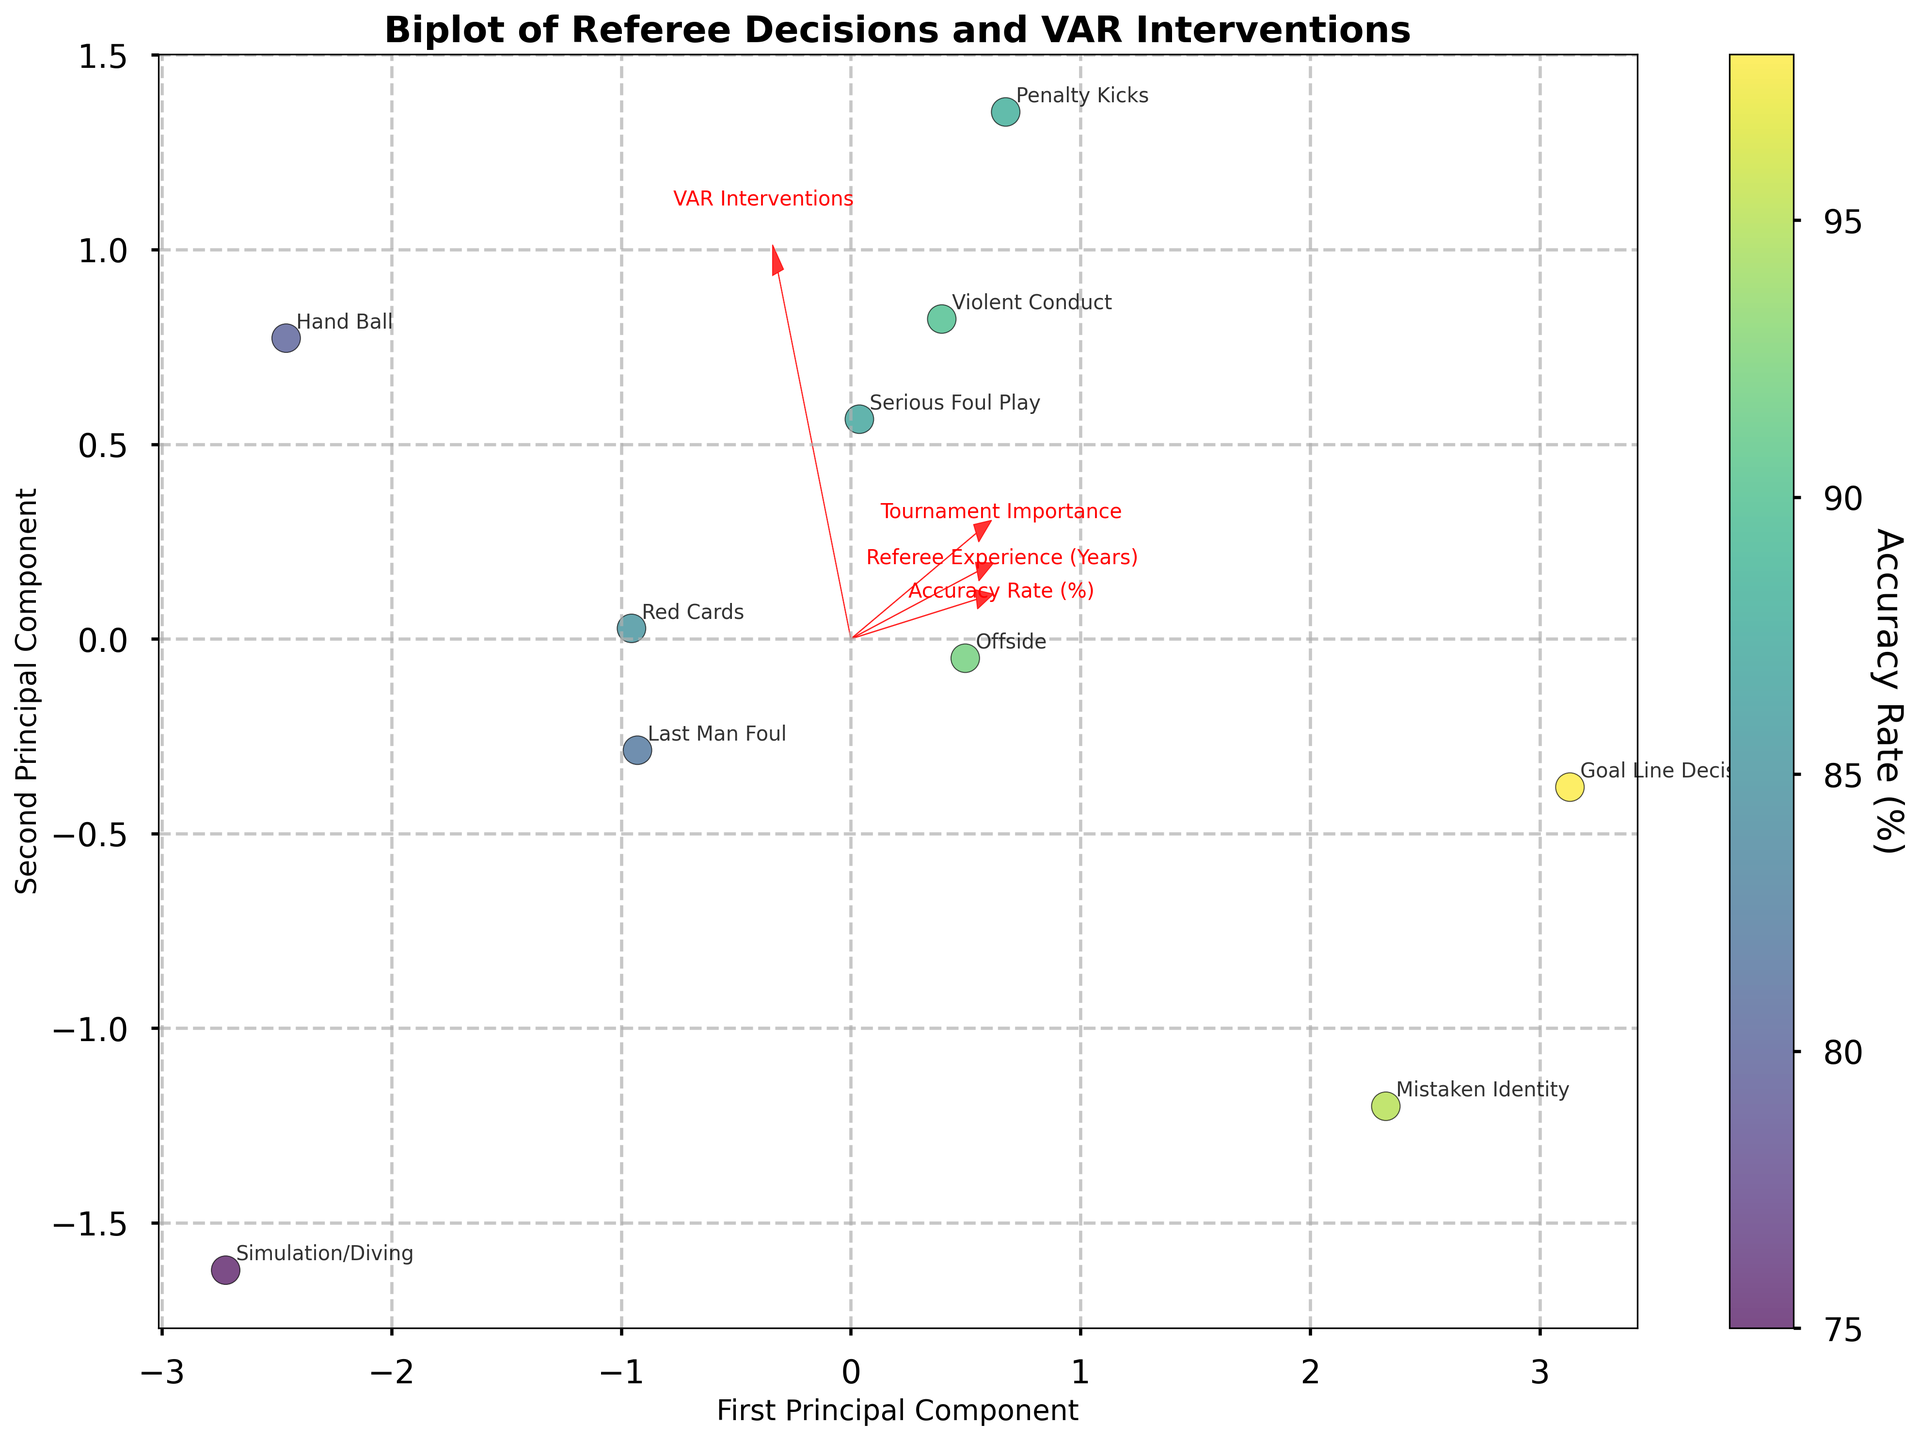What's the title of the plot? The title can usually be found at the top center of the plot and in this case, it reads "Biplot of Referee Decisions and VAR Interventions".
Answer: Biplot of Referee Decisions and VAR Interventions How many principal components are displayed on the axes? The plot shows two axes, each representing a principal component since it's a 2-component PCA biplot.
Answer: 2 What is the label of the color bar? The color bar on the right side of the plot is labeled "Accuracy Rate (%)".
Answer: Accuracy Rate (%) Which decision type has the highest Accuracy Rate (%)? Look for the data point clustered furthest to the right and highest on the color bar. "Goal Line Decisions" are positioned at 98%.
Answer: Goal Line Decisions Which feature vector points most horizontally to the right? Observe the red arrows indicating feature vectors. The arrow labeled "Accuracy Rate (%)" points most horizontally to the right direction.
Answer: Accuracy Rate (%) What's the general trend between Accuracy Rate (%) and VAR Interventions based on the biplot? Look at the direction of the arrows for "Accuracy Rate (%)" and "VAR Interventions". They point in roughly orthogonal directions, indicating these variables might not correlate strongly.
Answer: They are not strongly correlated Which decision type has both high VAR Interventions and high Tournament Importance? Locate the point closest to where the vectors "VAR Interventions" and "Tournament Importance" both extend. "Penalty Kicks" is near this region.
Answer: Penalty Kicks Are more experienced referees associated with higher decision accuracy based on the plot? Observe the vector for "Referee Experience (Years)" and compare its direction with "Accuracy Rate (%)". Both arrows point in generally the same direction, suggesting a correlation.
Answer: Yes, they are associated Which variable contributes the least to the first principal component? Identify the shortest arrow amongst the feature vectors. "Simulation/Diving" appears to have the least contribution.
Answer: Simulation/Diving Which decision type has the lowest accuracy rate, and how is it represented in the plot? "Simulation/Diving" has a low Accuracy Rate (%) of 75%, look for its position close to the bottom left of the color gradient.
Answer: Simulation/Diving 